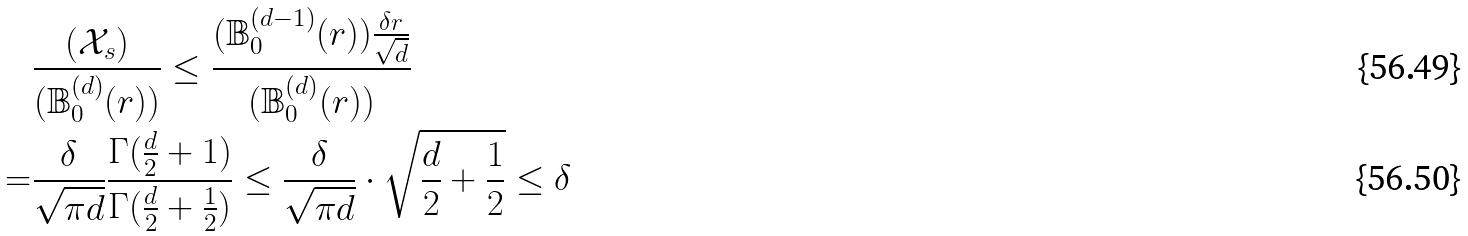Convert formula to latex. <formula><loc_0><loc_0><loc_500><loc_500>& \frac { ( \mathcal { X } _ { s } ) } { ( \mathbb { B } _ { 0 } ^ { ( d ) } ( r ) ) } \leq \frac { ( \mathbb { B } _ { 0 } ^ { ( d - 1 ) } ( r ) ) \frac { \delta r } { \sqrt { d } } } { ( \mathbb { B } _ { 0 } ^ { ( d ) } ( r ) ) } \\ = & \frac { \delta } { \sqrt { \pi d } } \frac { \Gamma ( \frac { d } { 2 } + 1 ) } { \Gamma ( \frac { d } { 2 } + \frac { 1 } { 2 } ) } \leq \frac { \delta } { \sqrt { \pi d } } \cdot \sqrt { \frac { d } { 2 } + \frac { 1 } { 2 } } \leq \delta</formula> 